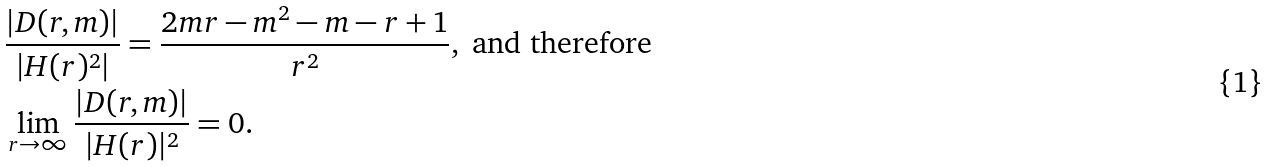Convert formula to latex. <formula><loc_0><loc_0><loc_500><loc_500>& \frac { | D ( r , m ) | } { | H ( r ) ^ { 2 } | } = \frac { 2 m r - m ^ { 2 } - m - r + 1 } { r ^ { 2 } } , \text { and therefore} \\ & \lim _ { r \rightarrow \infty } \frac { | D ( r , m ) | } { | H ( r ) | ^ { 2 } } = 0 .</formula> 